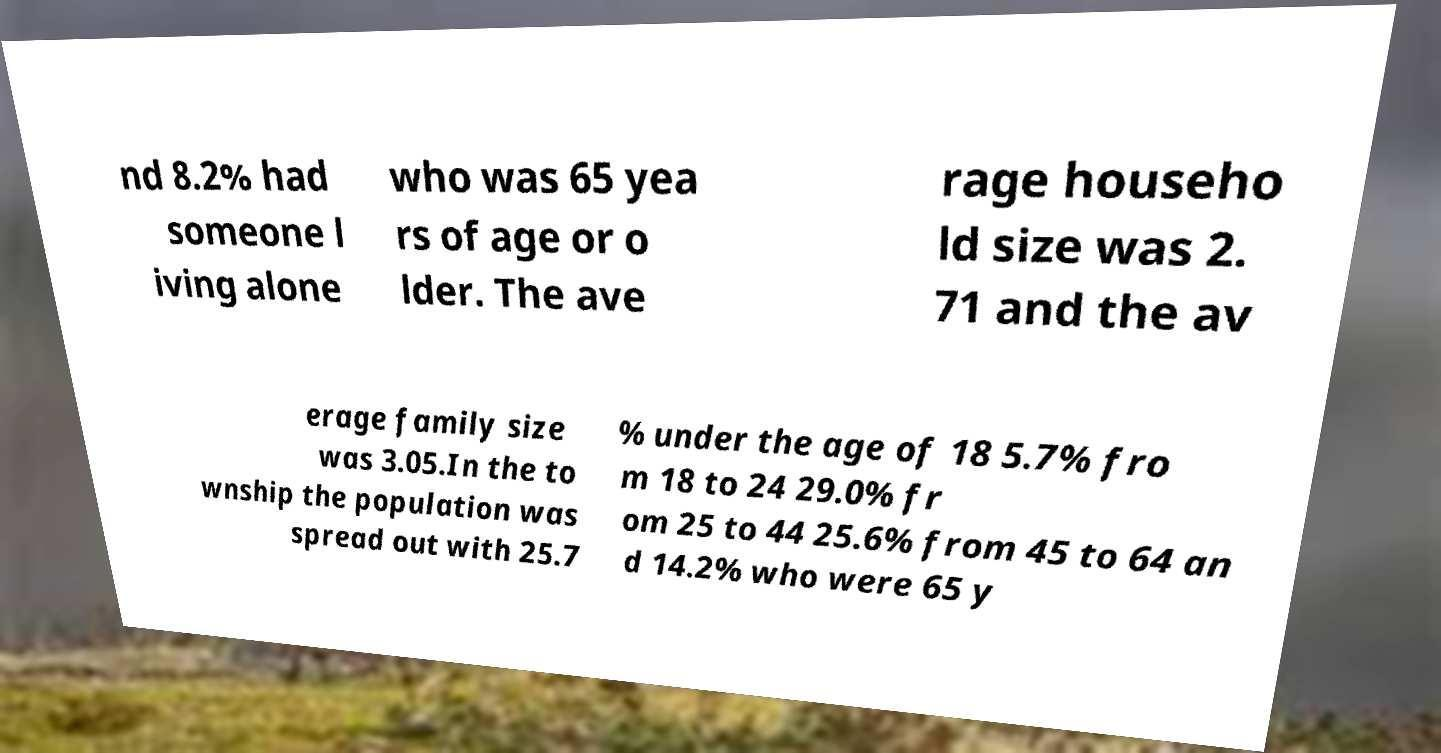Can you accurately transcribe the text from the provided image for me? nd 8.2% had someone l iving alone who was 65 yea rs of age or o lder. The ave rage househo ld size was 2. 71 and the av erage family size was 3.05.In the to wnship the population was spread out with 25.7 % under the age of 18 5.7% fro m 18 to 24 29.0% fr om 25 to 44 25.6% from 45 to 64 an d 14.2% who were 65 y 